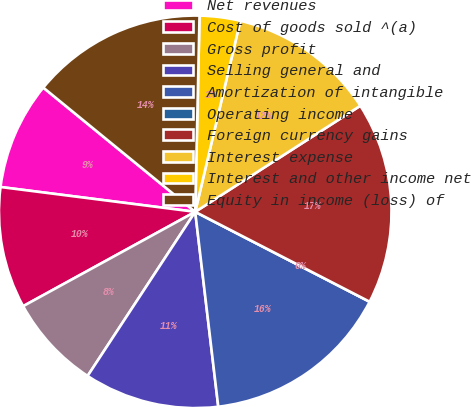<chart> <loc_0><loc_0><loc_500><loc_500><pie_chart><fcel>Net revenues<fcel>Cost of goods sold ^(a)<fcel>Gross profit<fcel>Selling general and<fcel>Amortization of intangible<fcel>Operating income<fcel>Foreign currency gains<fcel>Interest expense<fcel>Interest and other income net<fcel>Equity in income (loss) of<nl><fcel>8.89%<fcel>10.0%<fcel>7.78%<fcel>11.11%<fcel>15.55%<fcel>0.0%<fcel>16.66%<fcel>12.22%<fcel>3.34%<fcel>14.44%<nl></chart> 